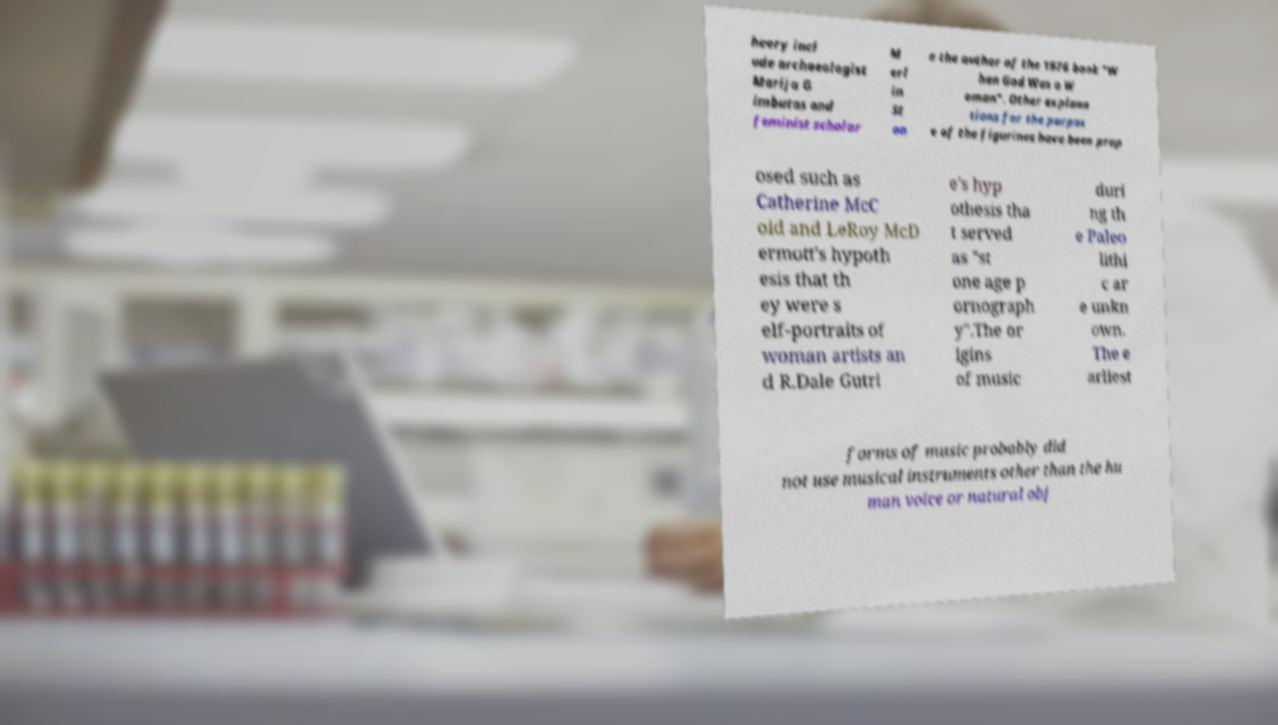Please read and relay the text visible in this image. What does it say? heory incl ude archaeologist Marija G imbutas and feminist scholar M erl in St on e the author of the 1976 book "W hen God Was a W oman". Other explana tions for the purpos e of the figurines have been prop osed such as Catherine McC oid and LeRoy McD ermott's hypoth esis that th ey were s elf-portraits of woman artists an d R.Dale Gutri e's hyp othesis tha t served as "st one age p ornograph y".The or igins of music duri ng th e Paleo lithi c ar e unkn own. The e arliest forms of music probably did not use musical instruments other than the hu man voice or natural obj 